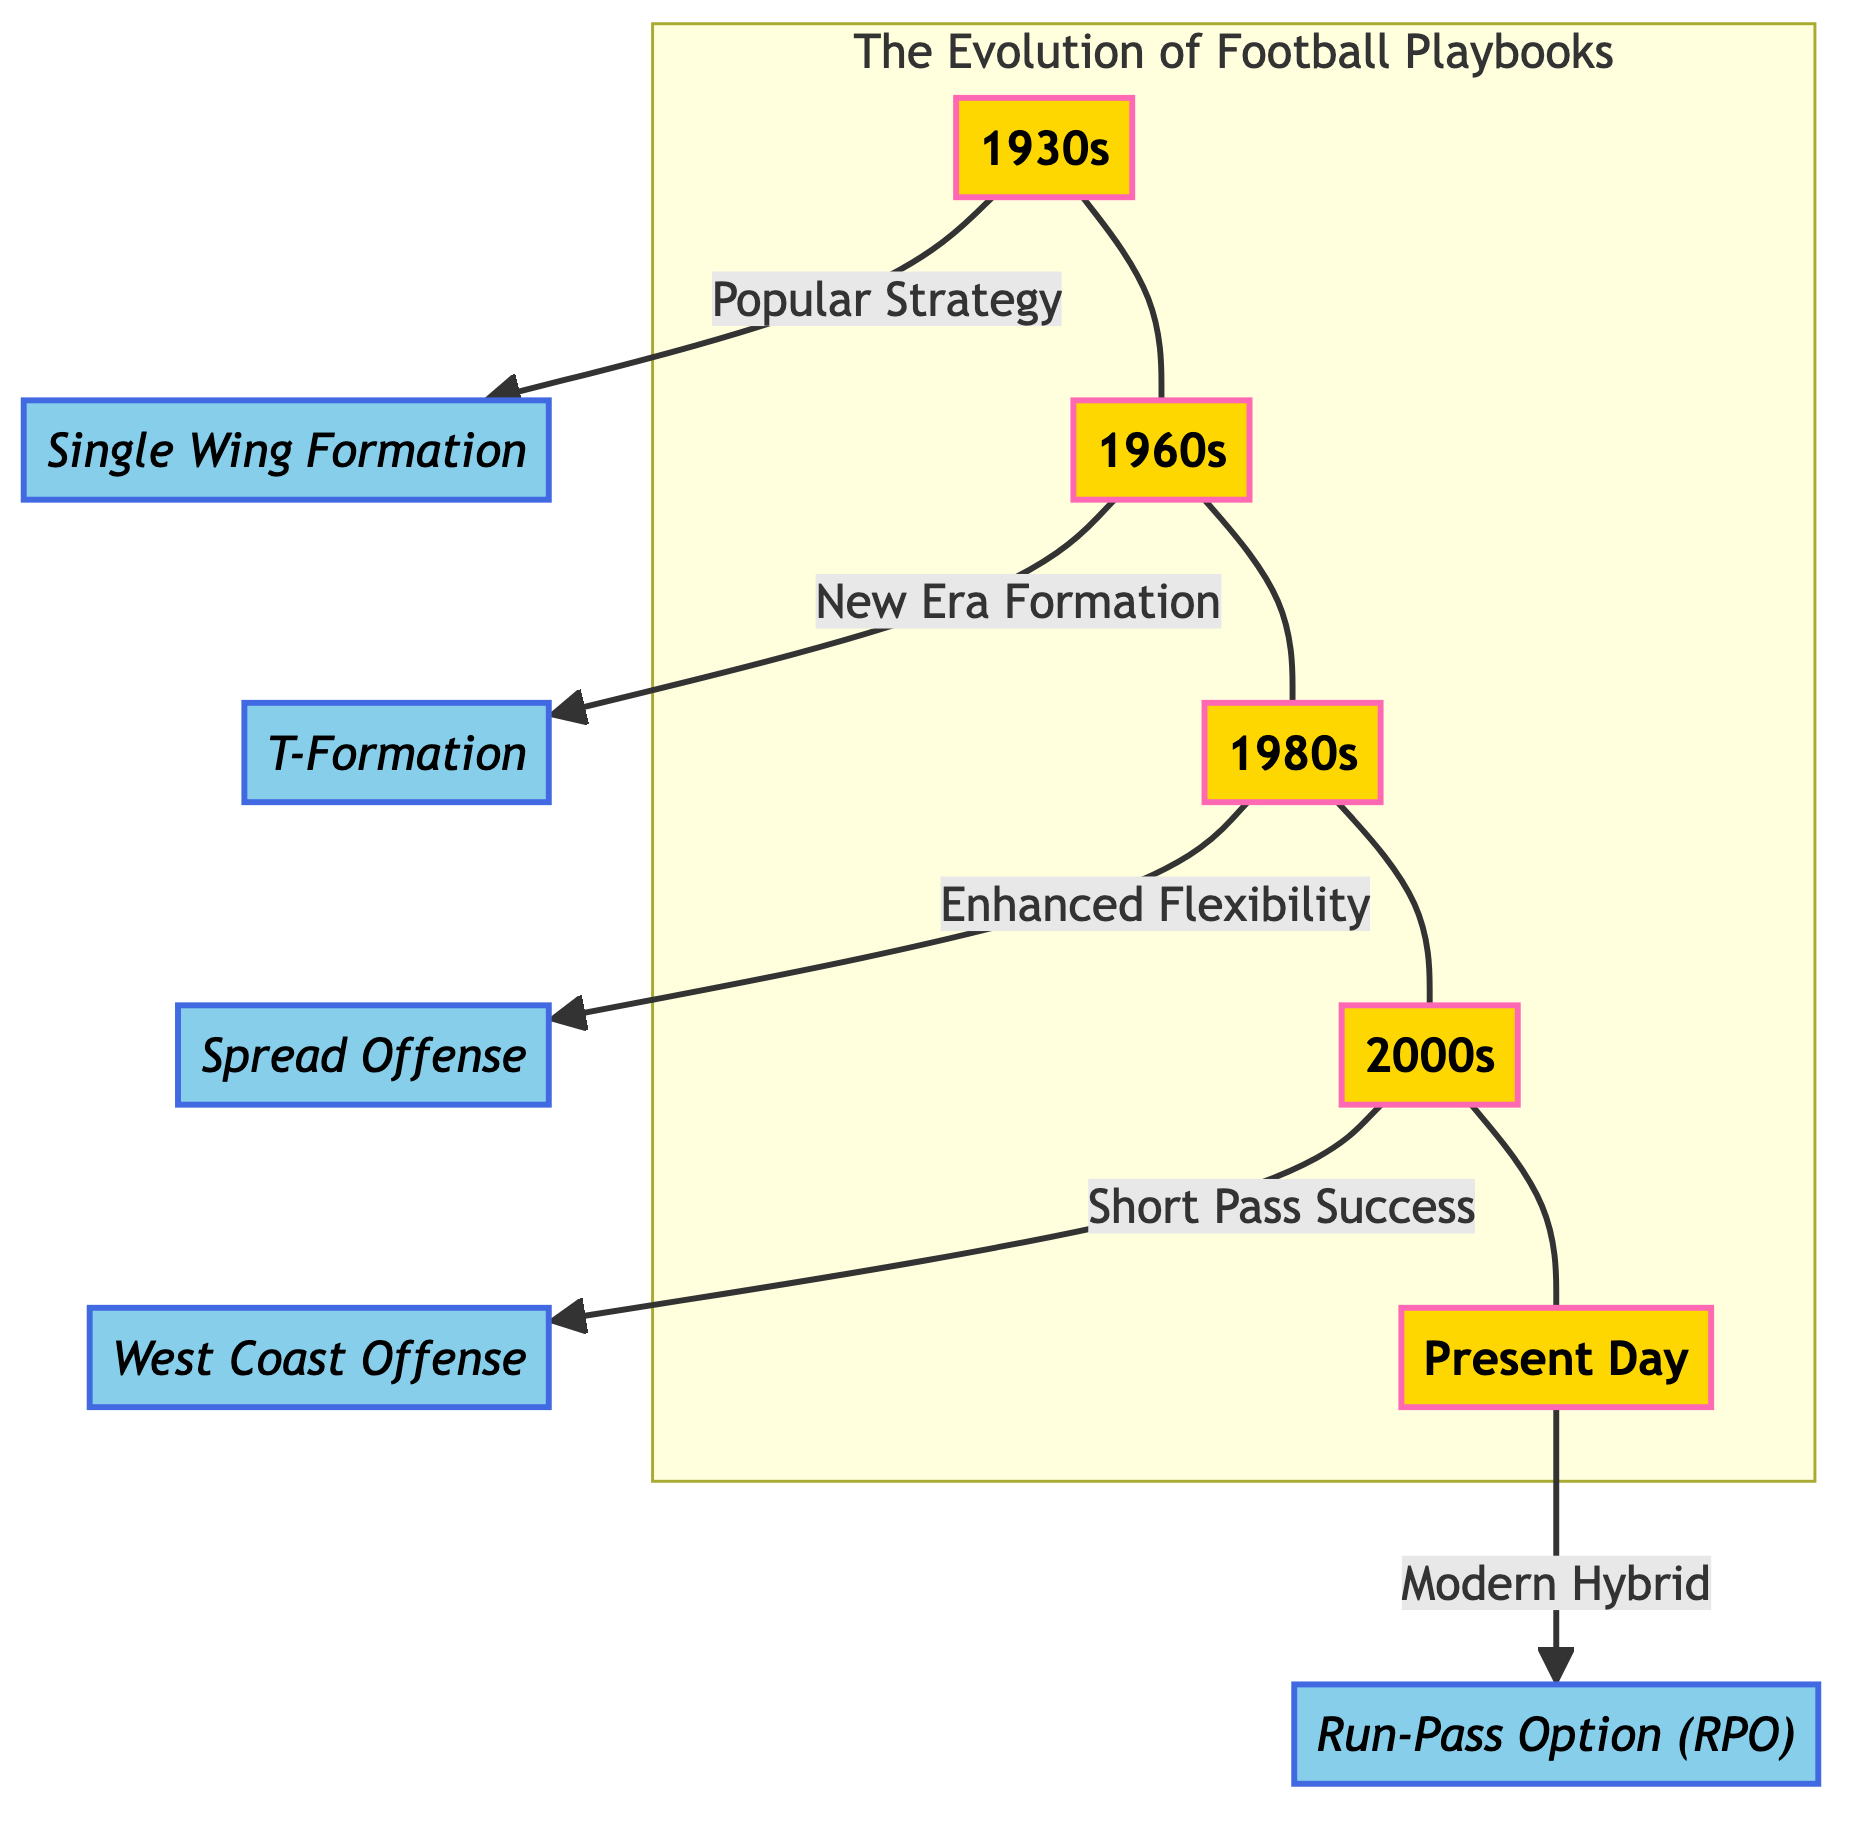What is the most recent formation presented in the diagram? The diagram outlines the evolution of football playbooks, concluding with the formation derived from the present day, which is represented by the node labeled "Run-Pass Option (RPO)."
Answer: Run-Pass Option (RPO) Which decade is associated with the T-Formation? The T-Formation follows the timeline presented and is directly linked to the decade represented by the node labeled "1960s."
Answer: 1960s How many strategies are listed in the diagram? The diagram lists five different strategies across various decades: Single Wing Formation, T-Formation, Spread Offense, West Coast Offense, and Run-Pass Option (RPO). Counting these gives a total of five strategies.
Answer: 5 What strategy is linked to the 1930s? In the diagram's structure, the strategy that corresponds to the 1930s, indicated by the arrow from that node, is the Single Wing Formation.
Answer: Single Wing Formation Which formation emphasizes short pass success? The diagram indicates that the formation featuring short pass success is associated with the 2000s and is labeled as the West Coast Offense.
Answer: West Coast Offense How does the strategy for the 1980s differ from that of the 1960s? The 1980s strategy emphasizes enhanced flexibility, while the 1960s strategy is focused on the T-Formation, which implies a more rigid structure; thus, the key difference is in their adaptability on the field.
Answer: Enhanced flexibility vs. T-Formation Which strategy marks the transition into modern playbooks? The diagram illustrates that the strategy marking the transition into modern playbooks is the Run-Pass Option (RPO), as it is placed at the final node representing the present day.
Answer: Run-Pass Option (RPO) What type of diagram is this? Based on its structure and the method in which the information is organized, the diagram can be categorized as a flowchart, demonstrating the evolution of playbooks through connected nodes.
Answer: Flowchart 